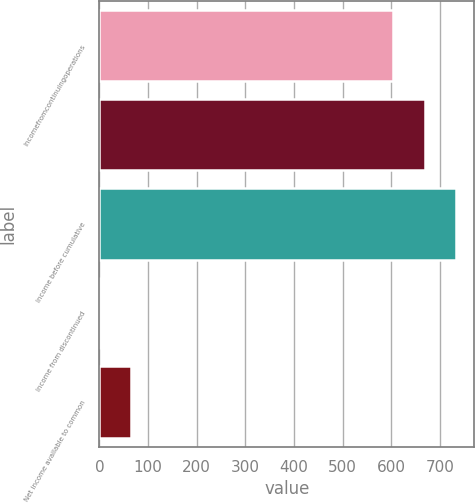Convert chart. <chart><loc_0><loc_0><loc_500><loc_500><bar_chart><fcel>Incomefromcontinuingoperations<fcel>Unnamed: 1<fcel>Income before cumulative<fcel>Income from discontinued<fcel>Net income available to common<nl><fcel>604<fcel>668.99<fcel>733.98<fcel>0.06<fcel>65.05<nl></chart> 